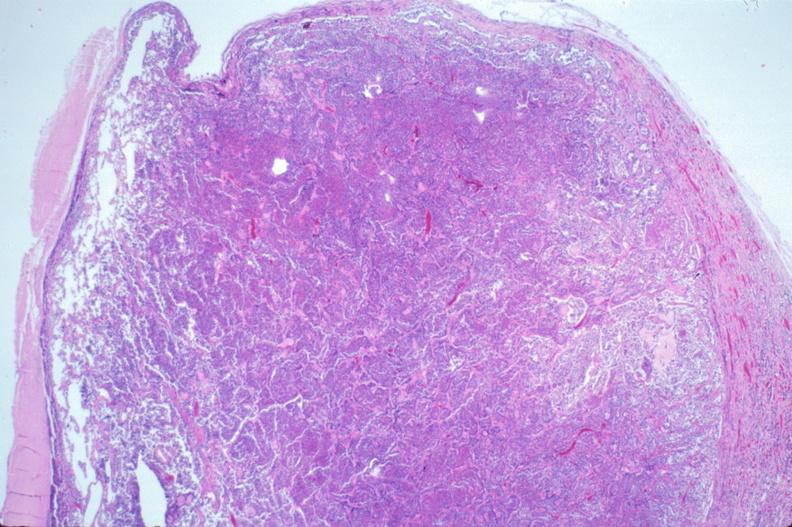does this image show pituitary, chromaphobe adenoma?
Answer the question using a single word or phrase. Yes 